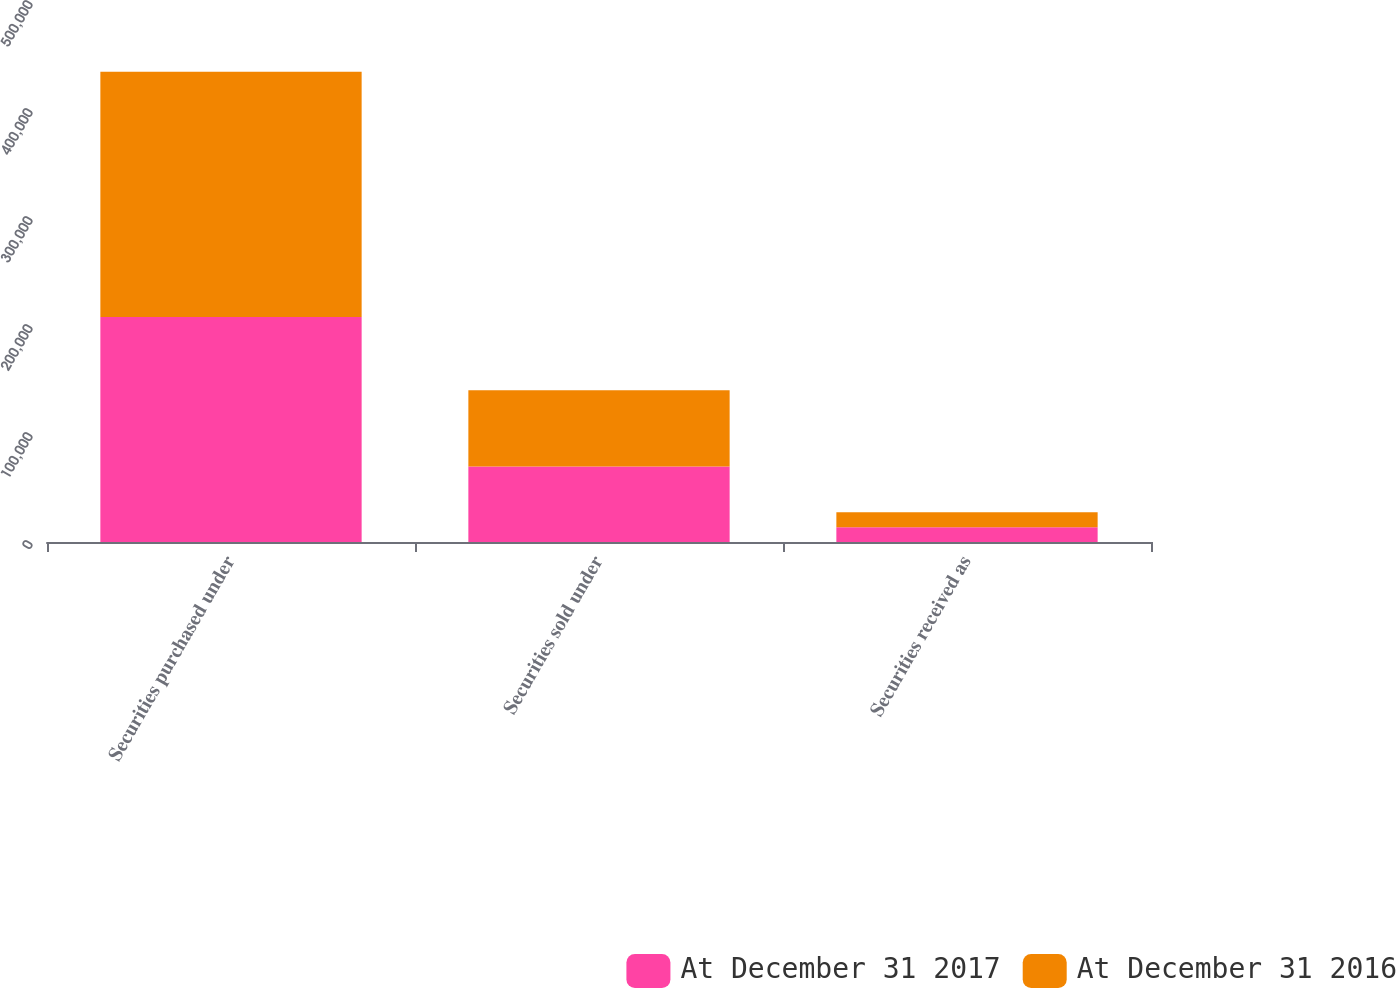Convert chart to OTSL. <chart><loc_0><loc_0><loc_500><loc_500><stacked_bar_chart><ecel><fcel>Securities purchased under<fcel>Securities sold under<fcel>Securities received as<nl><fcel>At December 31 2017<fcel>208268<fcel>70016<fcel>13749<nl><fcel>At December 31 2016<fcel>227191<fcel>70472<fcel>13737<nl></chart> 